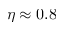Convert formula to latex. <formula><loc_0><loc_0><loc_500><loc_500>\eta \approx 0 . 8</formula> 